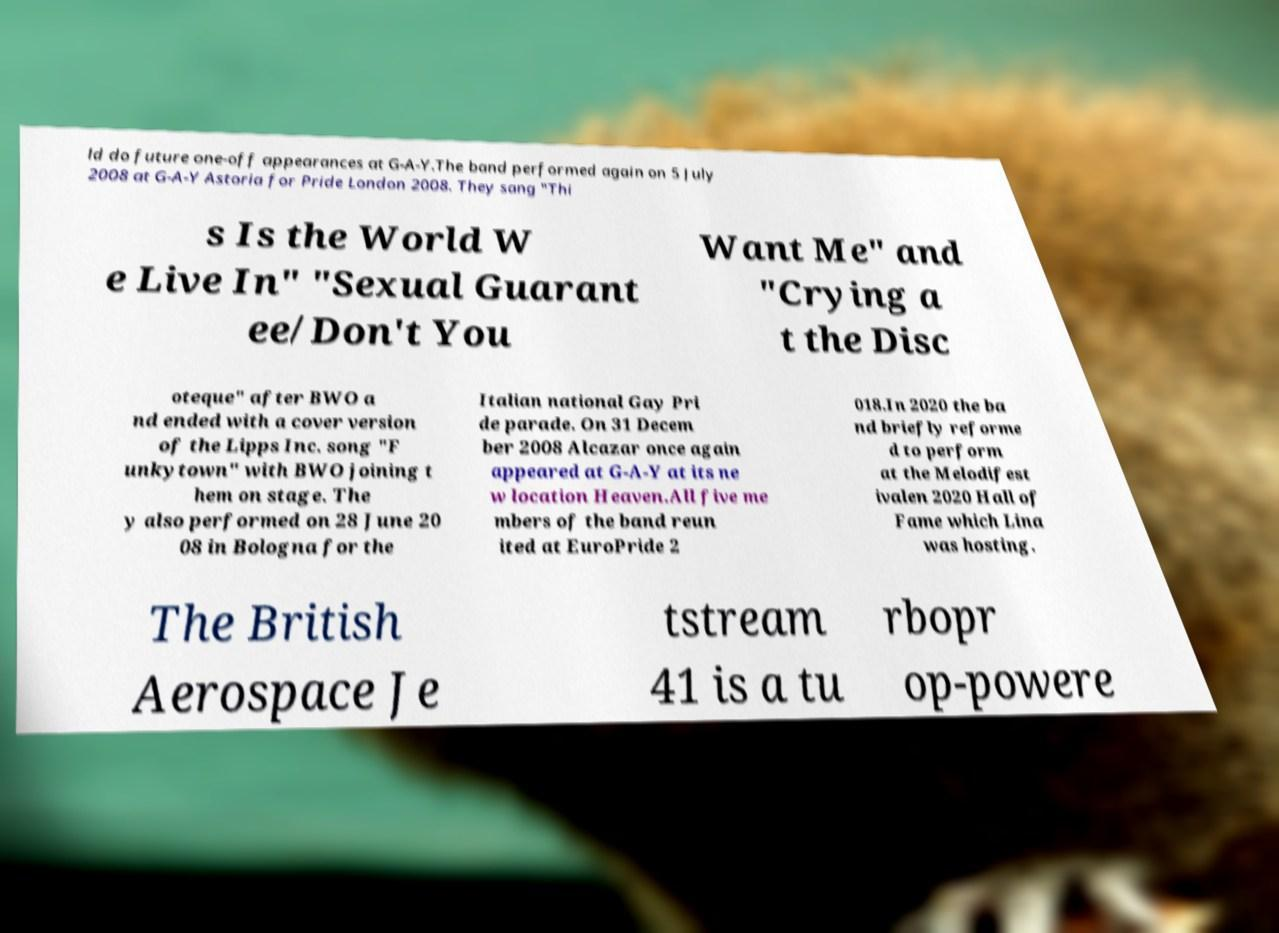For documentation purposes, I need the text within this image transcribed. Could you provide that? ld do future one-off appearances at G-A-Y.The band performed again on 5 July 2008 at G-A-Y Astoria for Pride London 2008. They sang "Thi s Is the World W e Live In" "Sexual Guarant ee/Don't You Want Me" and "Crying a t the Disc oteque" after BWO a nd ended with a cover version of the Lipps Inc. song "F unkytown" with BWO joining t hem on stage. The y also performed on 28 June 20 08 in Bologna for the Italian national Gay Pri de parade. On 31 Decem ber 2008 Alcazar once again appeared at G-A-Y at its ne w location Heaven.All five me mbers of the band reun ited at EuroPride 2 018.In 2020 the ba nd briefly reforme d to perform at the Melodifest ivalen 2020 Hall of Fame which Lina was hosting. The British Aerospace Je tstream 41 is a tu rbopr op-powere 